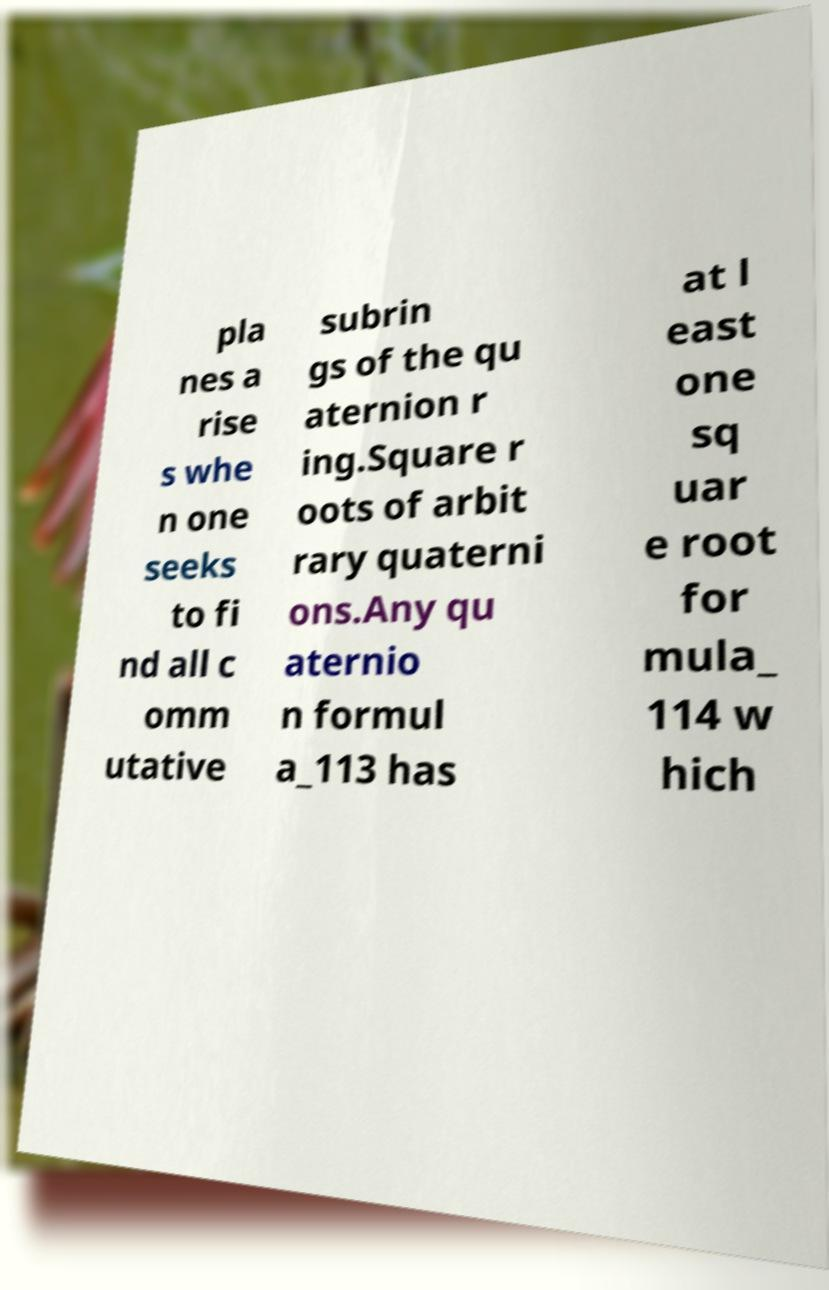Please identify and transcribe the text found in this image. pla nes a rise s whe n one seeks to fi nd all c omm utative subrin gs of the qu aternion r ing.Square r oots of arbit rary quaterni ons.Any qu aternio n formul a_113 has at l east one sq uar e root for mula_ 114 w hich 